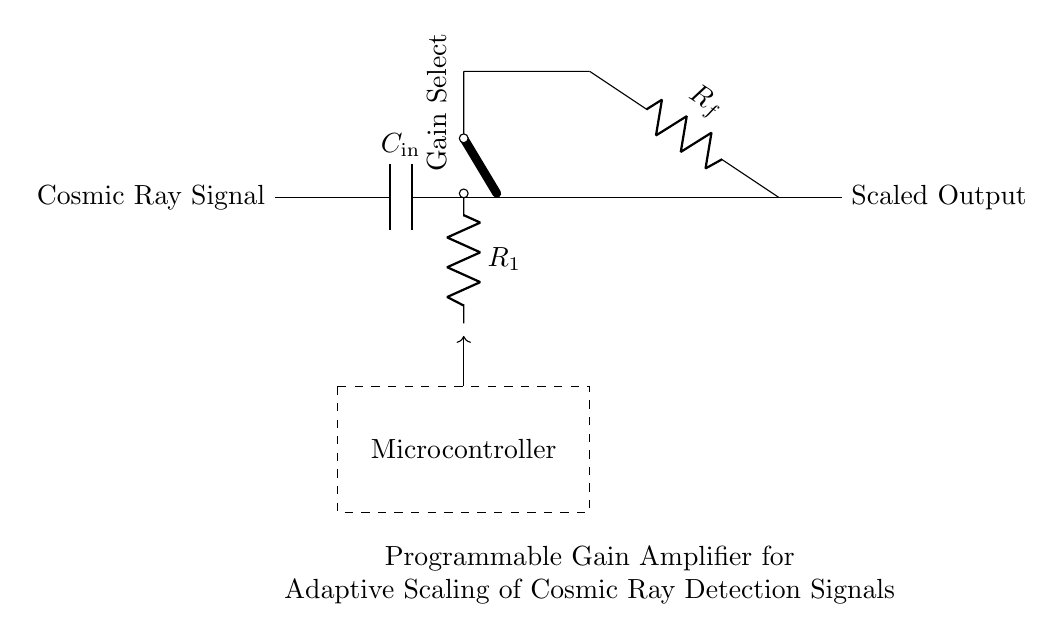What is the purpose of the capacitor labeled C-in? The capacitor C-in is used to couple the incoming cosmic ray signal to the amplifier while blocking any DC offset that might exist in the signal source. It helps ensure that only the AC components of the signal are amplified.
Answer: Coupling What component provides the programmable gain functionality? The component responsible for the programmable gain functionality is the operational amplifier, labeled as PGA in the diagram, which is configured with a feedback resistor that can be adjusted to change the gain.
Answer: PGA What does the microcontroller control in this circuit? The microcontroller controls the gain selection for the programmable gain amplifier, allowing for adaptive scaling of the detection signals based on the cosmic ray intensity.
Answer: Gain Select Which component would be used to adjust the gain of the amplifier? The gain of the amplifier can be adjusted using the feedback resistor R-f, which works in conjunction with the input resistance to determine the overall gain of the amplifier.
Answer: R-f What is indicated by the dashed rectangle in the circuit? The dashed rectangle indicates the area housing the microcontroller, which is responsible for controlling the gain of the amplifier based on the detected signal characteristics and cosmic ray intensity.
Answer: Microcontroller What type of signals does the circuit primarily process? The circuit primarily processes cosmic ray detection signals, which are generated by cosmic radiation impacting sensors and require amplification for further analysis.
Answer: Cosmic ray signals 